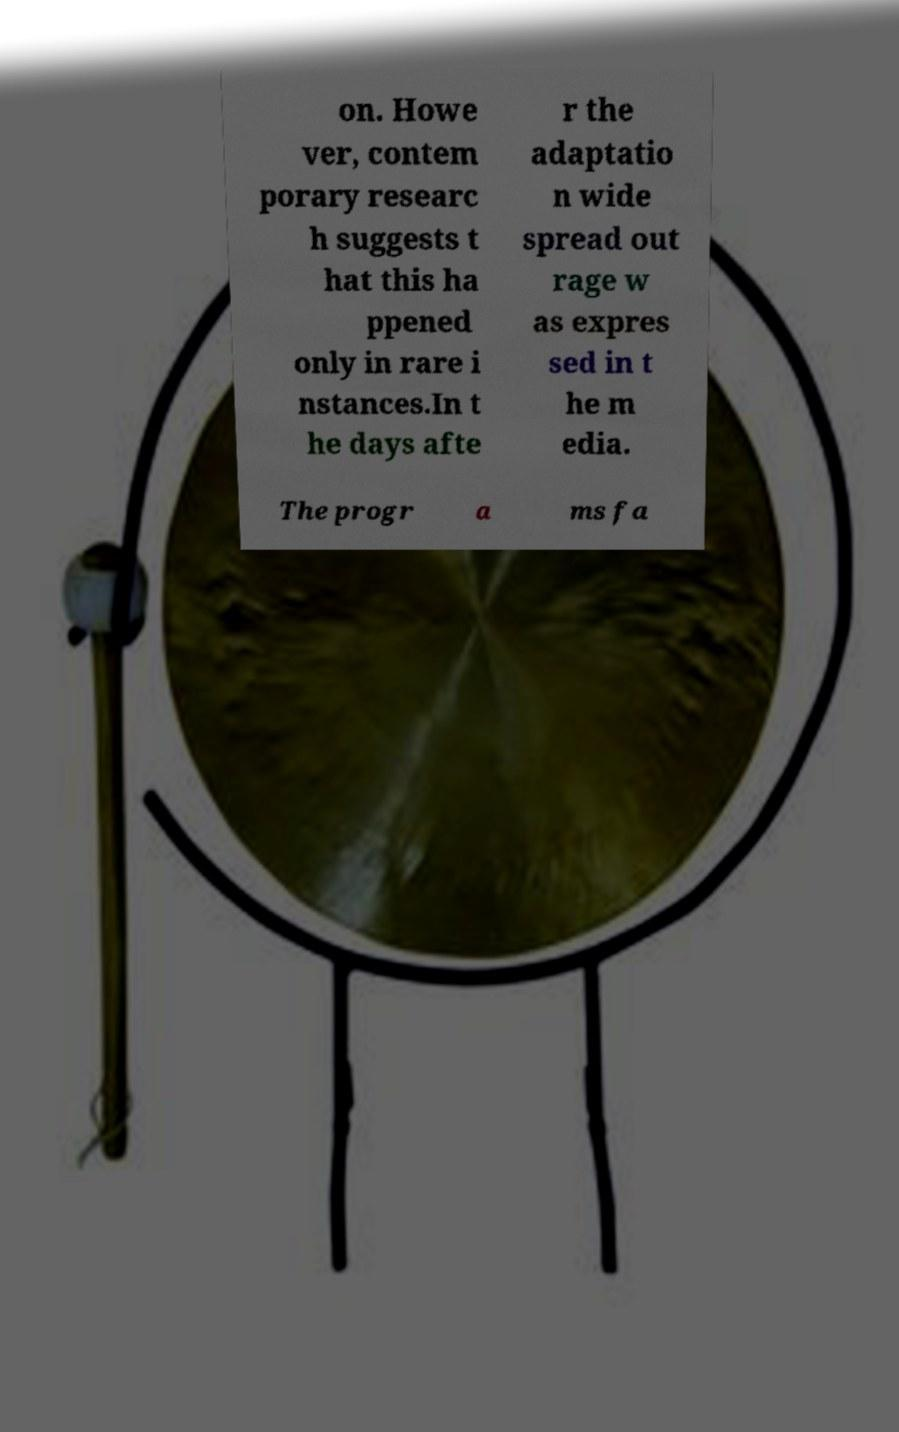Can you accurately transcribe the text from the provided image for me? on. Howe ver, contem porary researc h suggests t hat this ha ppened only in rare i nstances.In t he days afte r the adaptatio n wide spread out rage w as expres sed in t he m edia. The progr a ms fa 